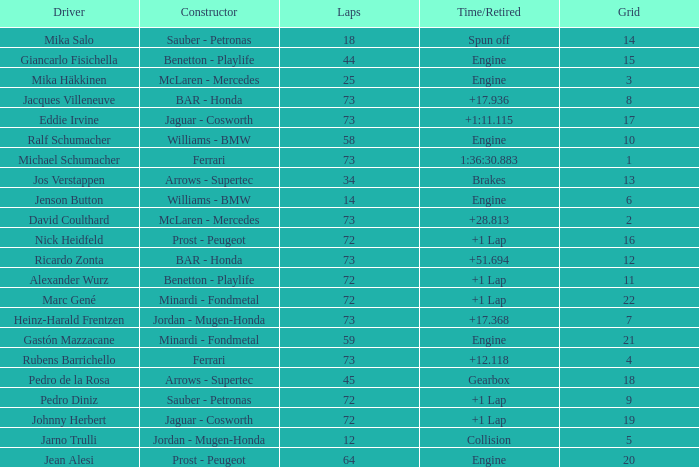How many laps did Giancarlo Fisichella do with a grid larger than 15? 0.0. 